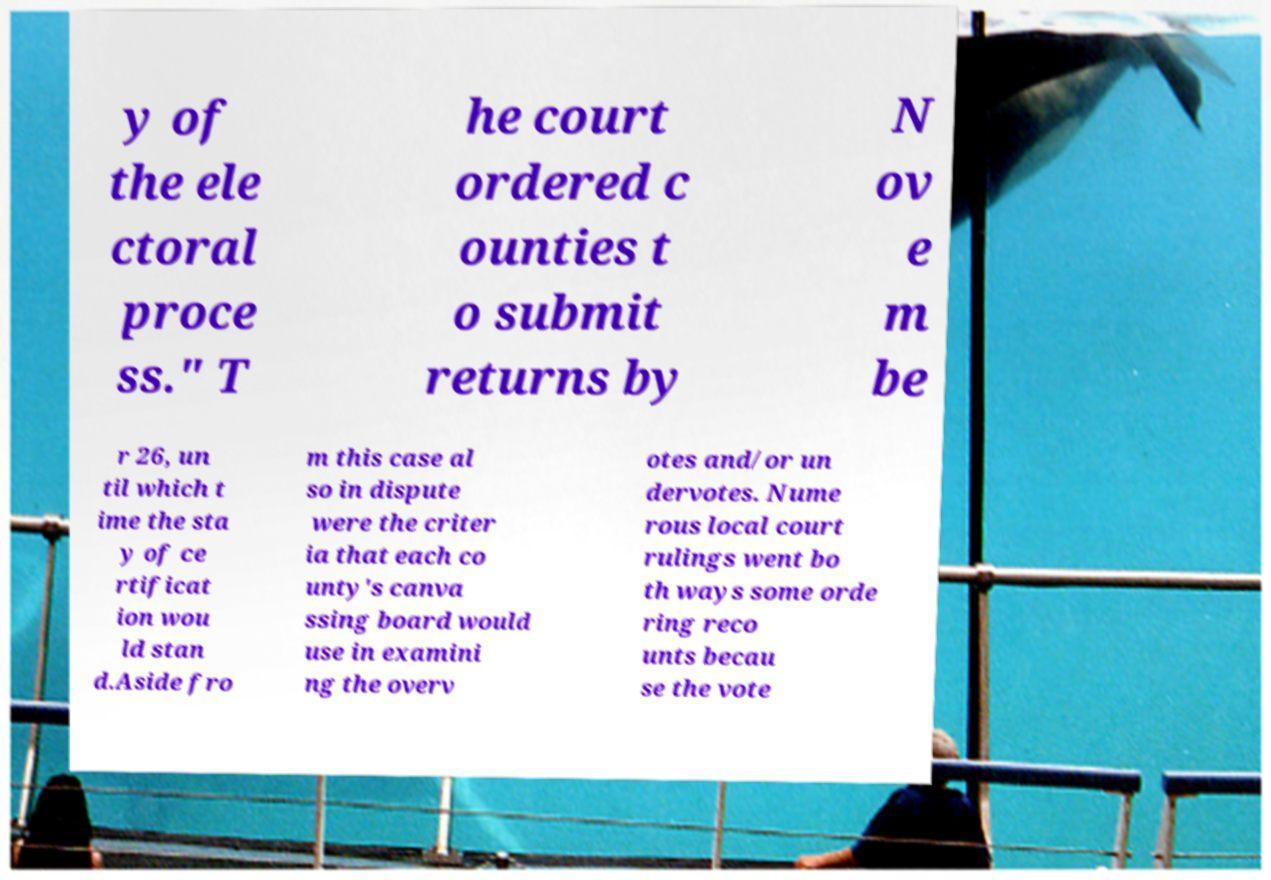Please identify and transcribe the text found in this image. y of the ele ctoral proce ss." T he court ordered c ounties t o submit returns by N ov e m be r 26, un til which t ime the sta y of ce rtificat ion wou ld stan d.Aside fro m this case al so in dispute were the criter ia that each co unty's canva ssing board would use in examini ng the overv otes and/or un dervotes. Nume rous local court rulings went bo th ways some orde ring reco unts becau se the vote 